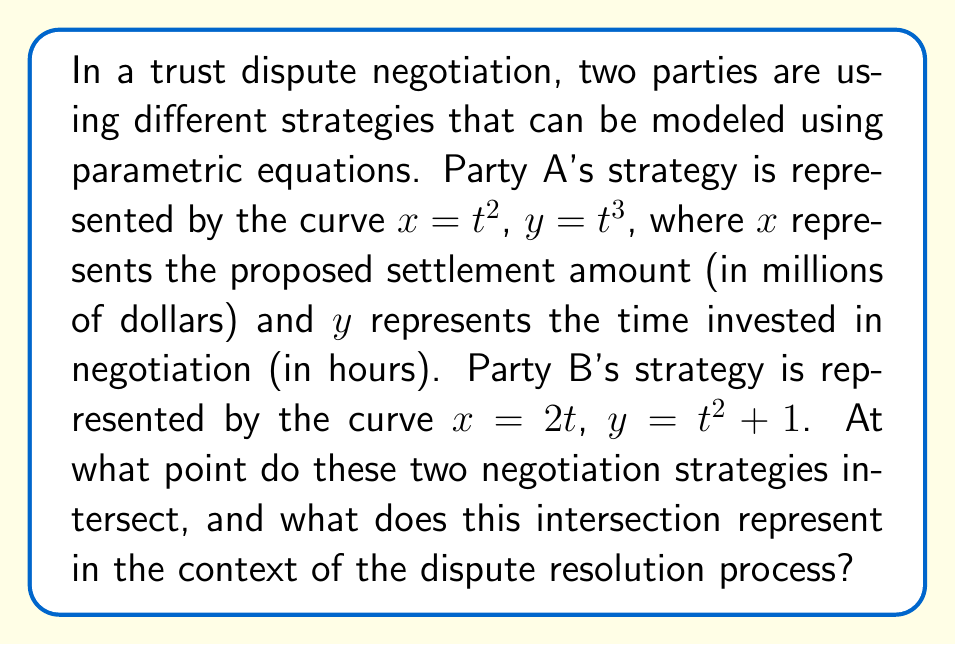Could you help me with this problem? To solve this problem, we need to find the point where the two parametric curves intersect. This involves equating the x and y components of both curves:

1) First, let's equate the x-components:
   $t^2 = 2t$

2) Solve this equation:
   $t^2 - 2t = 0$
   $t(t - 2) = 0$
   $t = 0$ or $t = 2$

3) Since $t = 0$ would result in $(0,0)$ for Party A and $(0,1)$ for Party B, which don't intersect, we'll use $t = 2$.

4) Now, let's verify if this t-value satisfies the y-component equation:

   For Party A: $y = t^3 = 2^3 = 8$
   For Party B: $y = t^2 + 1 = 2^2 + 1 = 5$

   These y-values are not equal, so $t = 2$ is not the solution.

5) Let's try equating the y-components instead:
   $t^3 = t^2 + 1$

6) Rearrange the equation:
   $t^3 - t^2 - 1 = 0$

7) This is a cubic equation. One solution is evident: $t = 1$. Let's verify if this satisfies both equations:

   For Party A: $x = t^2 = 1^2 = 1$, $y = t^3 = 1^3 = 1$
   For Party B: $x = 2t = 2(1) = 2$, $y = t^2 + 1 = 1^2 + 1 = 2$

   These don't match, so $t = 1$ is not the solution.

8) The remaining possibility is that the curves intersect when $t = 2$ for Party A and $t = 2$ for Party B:

   For Party A: $x = 2^2 = 4$, $y = 2^3 = 8$
   For Party B: $x = 2(2) = 4$, $y = 2^2 + 1 = 5$

9) The x-coordinates match, but the y-coordinates don't. This means the curves intersect when the x-coordinate (settlement amount) is 4 million dollars, but at different times.

In the context of dispute resolution, this intersection represents a point where both parties agree on the settlement amount (4 million dollars), but they reach this agreement at different times in their negotiation processes. Party A reaches this point after 8 hours of negotiation, while Party B reaches it after 5 hours.
Answer: The negotiation strategies intersect at x = 4 million dollars, but at different y-values (times). Party A reaches this settlement amount after 8 hours of negotiation, while Party B reaches it after 5 hours. 